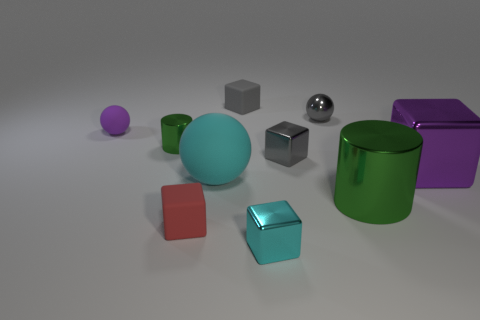Subtract all green cylinders. How many were subtracted if there are1green cylinders left? 1 Subtract all big metallic cubes. How many cubes are left? 4 Subtract all cyan blocks. How many blocks are left? 4 Subtract all yellow cubes. Subtract all cyan spheres. How many cubes are left? 5 Subtract all spheres. How many objects are left? 7 Subtract 0 blue cylinders. How many objects are left? 10 Subtract all matte blocks. Subtract all tiny green metallic cylinders. How many objects are left? 7 Add 9 small purple matte things. How many small purple matte things are left? 10 Add 6 blue metal cylinders. How many blue metal cylinders exist? 6 